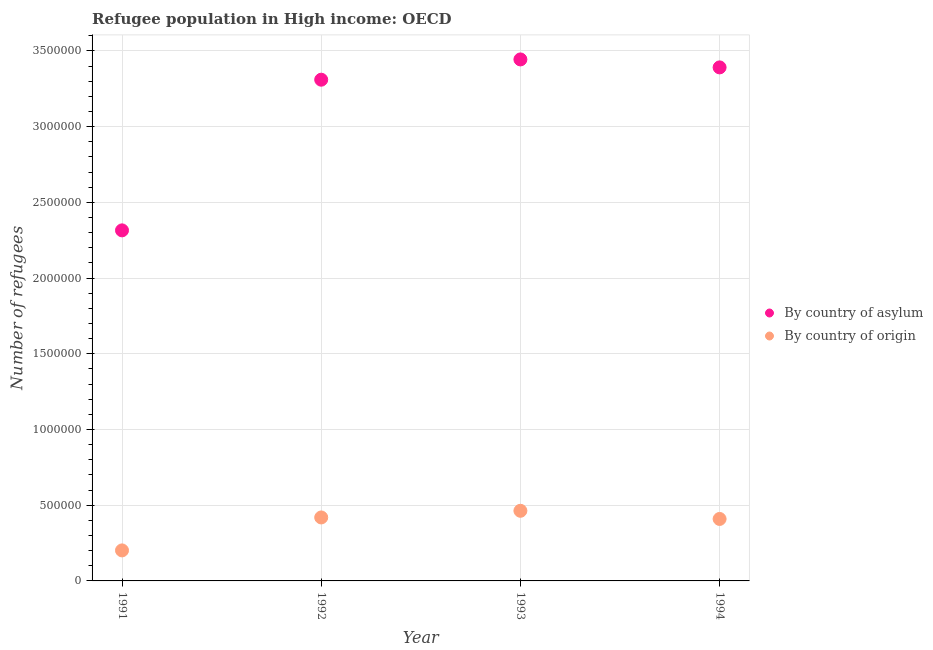What is the number of refugees by country of asylum in 1993?
Provide a short and direct response. 3.44e+06. Across all years, what is the maximum number of refugees by country of asylum?
Provide a succinct answer. 3.44e+06. Across all years, what is the minimum number of refugees by country of asylum?
Provide a succinct answer. 2.32e+06. In which year was the number of refugees by country of origin minimum?
Give a very brief answer. 1991. What is the total number of refugees by country of origin in the graph?
Your response must be concise. 1.49e+06. What is the difference between the number of refugees by country of origin in 1991 and that in 1994?
Your answer should be very brief. -2.08e+05. What is the difference between the number of refugees by country of origin in 1992 and the number of refugees by country of asylum in 1991?
Your response must be concise. -1.90e+06. What is the average number of refugees by country of asylum per year?
Give a very brief answer. 3.12e+06. In the year 1991, what is the difference between the number of refugees by country of origin and number of refugees by country of asylum?
Keep it short and to the point. -2.11e+06. In how many years, is the number of refugees by country of origin greater than 1800000?
Ensure brevity in your answer.  0. What is the ratio of the number of refugees by country of asylum in 1991 to that in 1992?
Provide a succinct answer. 0.7. What is the difference between the highest and the second highest number of refugees by country of origin?
Give a very brief answer. 4.39e+04. What is the difference between the highest and the lowest number of refugees by country of asylum?
Your answer should be very brief. 1.13e+06. Is the sum of the number of refugees by country of origin in 1992 and 1994 greater than the maximum number of refugees by country of asylum across all years?
Your response must be concise. No. Is the number of refugees by country of asylum strictly less than the number of refugees by country of origin over the years?
Offer a very short reply. No. What is the difference between two consecutive major ticks on the Y-axis?
Your response must be concise. 5.00e+05. How many legend labels are there?
Keep it short and to the point. 2. How are the legend labels stacked?
Offer a terse response. Vertical. What is the title of the graph?
Ensure brevity in your answer.  Refugee population in High income: OECD. What is the label or title of the X-axis?
Your answer should be very brief. Year. What is the label or title of the Y-axis?
Your response must be concise. Number of refugees. What is the Number of refugees in By country of asylum in 1991?
Give a very brief answer. 2.32e+06. What is the Number of refugees in By country of origin in 1991?
Provide a succinct answer. 2.02e+05. What is the Number of refugees of By country of asylum in 1992?
Provide a succinct answer. 3.31e+06. What is the Number of refugees in By country of origin in 1992?
Ensure brevity in your answer.  4.19e+05. What is the Number of refugees in By country of asylum in 1993?
Offer a terse response. 3.44e+06. What is the Number of refugees in By country of origin in 1993?
Provide a succinct answer. 4.63e+05. What is the Number of refugees in By country of asylum in 1994?
Give a very brief answer. 3.39e+06. What is the Number of refugees of By country of origin in 1994?
Provide a succinct answer. 4.09e+05. Across all years, what is the maximum Number of refugees in By country of asylum?
Provide a short and direct response. 3.44e+06. Across all years, what is the maximum Number of refugees in By country of origin?
Ensure brevity in your answer.  4.63e+05. Across all years, what is the minimum Number of refugees of By country of asylum?
Offer a terse response. 2.32e+06. Across all years, what is the minimum Number of refugees of By country of origin?
Offer a very short reply. 2.02e+05. What is the total Number of refugees of By country of asylum in the graph?
Keep it short and to the point. 1.25e+07. What is the total Number of refugees of By country of origin in the graph?
Offer a very short reply. 1.49e+06. What is the difference between the Number of refugees of By country of asylum in 1991 and that in 1992?
Make the answer very short. -9.95e+05. What is the difference between the Number of refugees of By country of origin in 1991 and that in 1992?
Provide a succinct answer. -2.18e+05. What is the difference between the Number of refugees of By country of asylum in 1991 and that in 1993?
Offer a very short reply. -1.13e+06. What is the difference between the Number of refugees in By country of origin in 1991 and that in 1993?
Your response must be concise. -2.62e+05. What is the difference between the Number of refugees of By country of asylum in 1991 and that in 1994?
Your response must be concise. -1.08e+06. What is the difference between the Number of refugees in By country of origin in 1991 and that in 1994?
Provide a succinct answer. -2.08e+05. What is the difference between the Number of refugees in By country of asylum in 1992 and that in 1993?
Keep it short and to the point. -1.34e+05. What is the difference between the Number of refugees in By country of origin in 1992 and that in 1993?
Offer a very short reply. -4.39e+04. What is the difference between the Number of refugees of By country of asylum in 1992 and that in 1994?
Keep it short and to the point. -8.13e+04. What is the difference between the Number of refugees in By country of origin in 1992 and that in 1994?
Make the answer very short. 9947. What is the difference between the Number of refugees in By country of asylum in 1993 and that in 1994?
Your answer should be very brief. 5.26e+04. What is the difference between the Number of refugees in By country of origin in 1993 and that in 1994?
Provide a succinct answer. 5.39e+04. What is the difference between the Number of refugees of By country of asylum in 1991 and the Number of refugees of By country of origin in 1992?
Give a very brief answer. 1.90e+06. What is the difference between the Number of refugees in By country of asylum in 1991 and the Number of refugees in By country of origin in 1993?
Offer a terse response. 1.85e+06. What is the difference between the Number of refugees in By country of asylum in 1991 and the Number of refugees in By country of origin in 1994?
Keep it short and to the point. 1.91e+06. What is the difference between the Number of refugees in By country of asylum in 1992 and the Number of refugees in By country of origin in 1993?
Give a very brief answer. 2.85e+06. What is the difference between the Number of refugees of By country of asylum in 1992 and the Number of refugees of By country of origin in 1994?
Your response must be concise. 2.90e+06. What is the difference between the Number of refugees in By country of asylum in 1993 and the Number of refugees in By country of origin in 1994?
Provide a succinct answer. 3.04e+06. What is the average Number of refugees in By country of asylum per year?
Provide a short and direct response. 3.12e+06. What is the average Number of refugees of By country of origin per year?
Ensure brevity in your answer.  3.73e+05. In the year 1991, what is the difference between the Number of refugees of By country of asylum and Number of refugees of By country of origin?
Provide a succinct answer. 2.11e+06. In the year 1992, what is the difference between the Number of refugees of By country of asylum and Number of refugees of By country of origin?
Keep it short and to the point. 2.89e+06. In the year 1993, what is the difference between the Number of refugees in By country of asylum and Number of refugees in By country of origin?
Offer a terse response. 2.98e+06. In the year 1994, what is the difference between the Number of refugees of By country of asylum and Number of refugees of By country of origin?
Provide a short and direct response. 2.98e+06. What is the ratio of the Number of refugees in By country of asylum in 1991 to that in 1992?
Make the answer very short. 0.7. What is the ratio of the Number of refugees in By country of origin in 1991 to that in 1992?
Your response must be concise. 0.48. What is the ratio of the Number of refugees of By country of asylum in 1991 to that in 1993?
Give a very brief answer. 0.67. What is the ratio of the Number of refugees in By country of origin in 1991 to that in 1993?
Provide a succinct answer. 0.44. What is the ratio of the Number of refugees in By country of asylum in 1991 to that in 1994?
Your response must be concise. 0.68. What is the ratio of the Number of refugees of By country of origin in 1991 to that in 1994?
Offer a terse response. 0.49. What is the ratio of the Number of refugees in By country of asylum in 1992 to that in 1993?
Your response must be concise. 0.96. What is the ratio of the Number of refugees of By country of origin in 1992 to that in 1993?
Provide a short and direct response. 0.91. What is the ratio of the Number of refugees in By country of origin in 1992 to that in 1994?
Your answer should be very brief. 1.02. What is the ratio of the Number of refugees in By country of asylum in 1993 to that in 1994?
Keep it short and to the point. 1.02. What is the ratio of the Number of refugees in By country of origin in 1993 to that in 1994?
Your answer should be compact. 1.13. What is the difference between the highest and the second highest Number of refugees in By country of asylum?
Make the answer very short. 5.26e+04. What is the difference between the highest and the second highest Number of refugees in By country of origin?
Ensure brevity in your answer.  4.39e+04. What is the difference between the highest and the lowest Number of refugees of By country of asylum?
Your response must be concise. 1.13e+06. What is the difference between the highest and the lowest Number of refugees of By country of origin?
Your answer should be compact. 2.62e+05. 